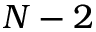<formula> <loc_0><loc_0><loc_500><loc_500>N - 2</formula> 